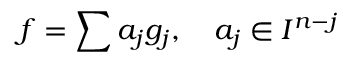Convert formula to latex. <formula><loc_0><loc_0><loc_500><loc_500>f = \sum a _ { j } g _ { j } , \quad a _ { j } \in I ^ { n - j }</formula> 